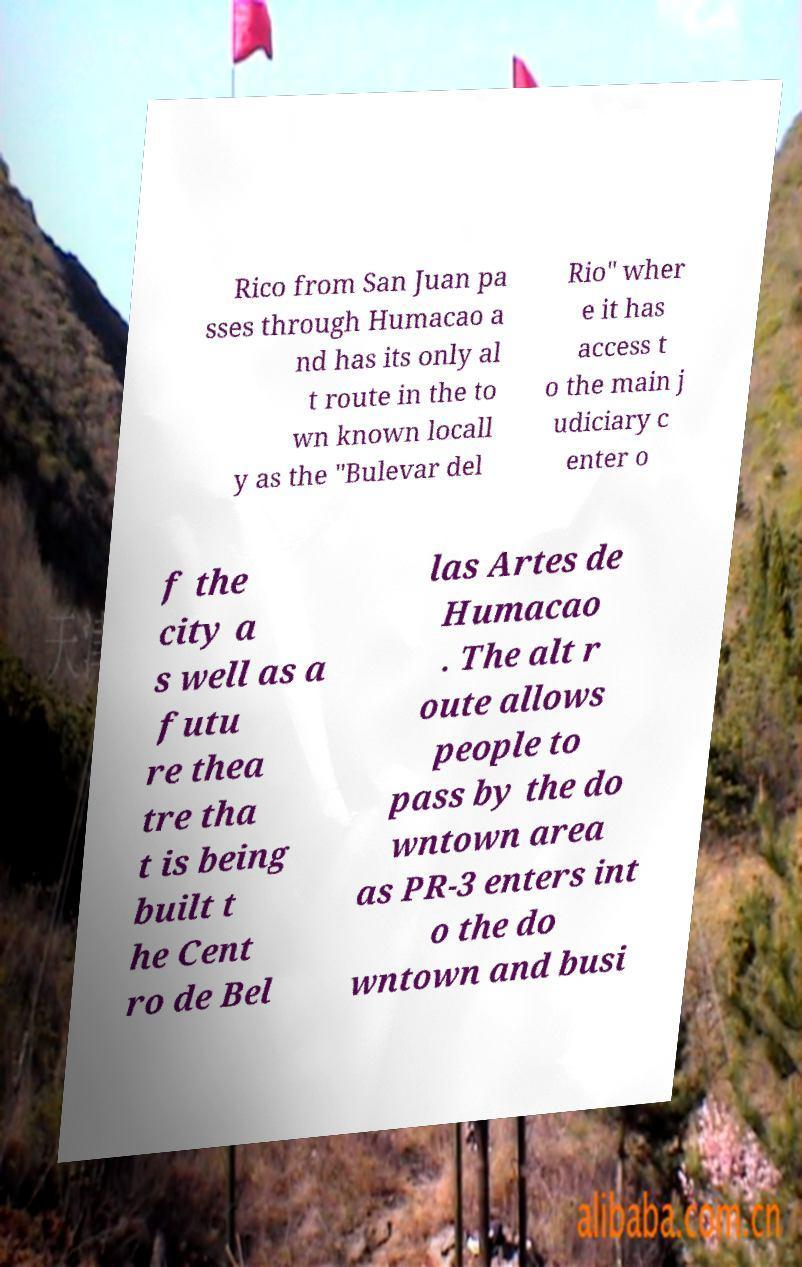Please identify and transcribe the text found in this image. Rico from San Juan pa sses through Humacao a nd has its only al t route in the to wn known locall y as the "Bulevar del Rio" wher e it has access t o the main j udiciary c enter o f the city a s well as a futu re thea tre tha t is being built t he Cent ro de Bel las Artes de Humacao . The alt r oute allows people to pass by the do wntown area as PR-3 enters int o the do wntown and busi 